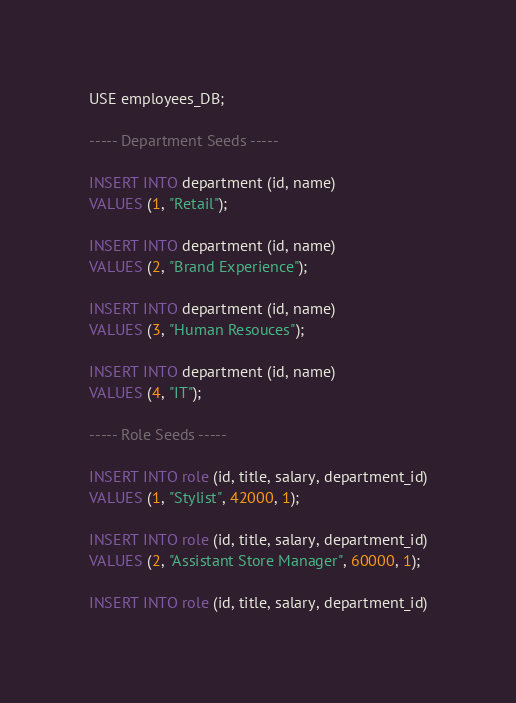Convert code to text. <code><loc_0><loc_0><loc_500><loc_500><_SQL_>USE employees_DB;

----- Department Seeds -----

INSERT INTO department (id, name)
VALUES (1, "Retail");

INSERT INTO department (id, name)
VALUES (2, "Brand Experience");

INSERT INTO department (id, name)
VALUES (3, "Human Resouces");

INSERT INTO department (id, name)
VALUES (4, "IT");

----- Role Seeds -----

INSERT INTO role (id, title, salary, department_id)
VALUES (1, "Stylist", 42000, 1);

INSERT INTO role (id, title, salary, department_id)
VALUES (2, "Assistant Store Manager", 60000, 1);

INSERT INTO role (id, title, salary, department_id)</code> 